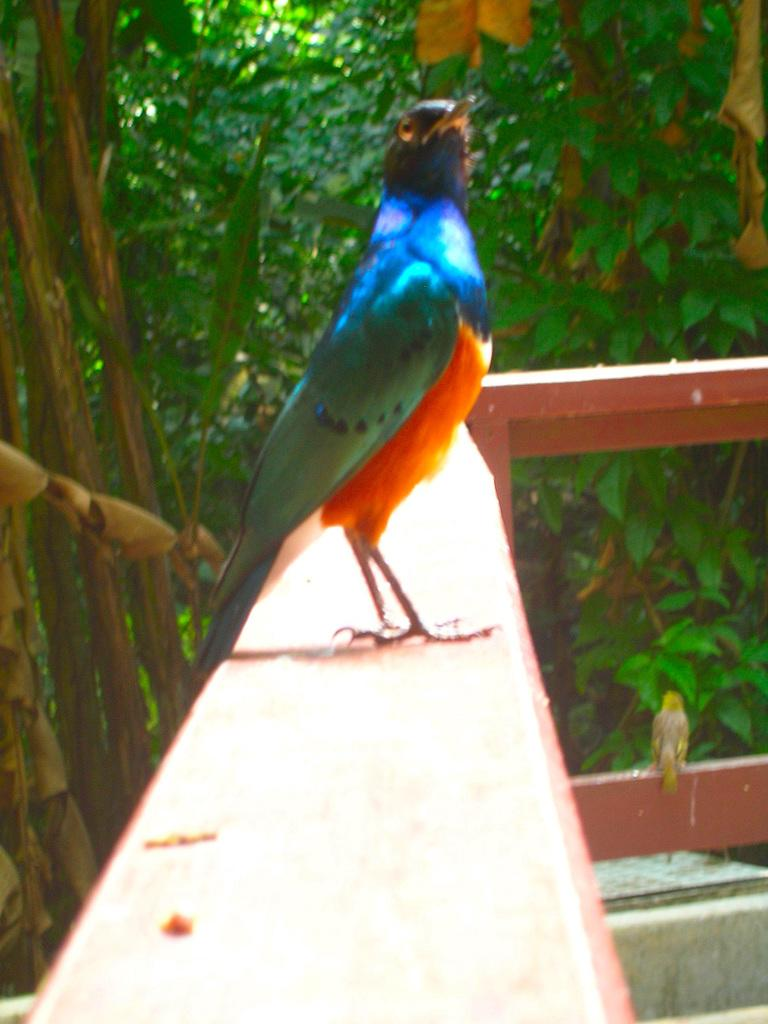What is the main object in the center of the image? There is a board in the center of the image. What can be seen at the bottom of the image? There is a fence at the bottom of the image. What type of natural scenery is visible in the background of the image? There are trees in the background of the image. What type of pleasure can be seen enjoying the drum in the image? There is no drum or pleasure present in the image; it features a board and a fence. Is there a carpenter working on the board in the image? The image does not provide information about whether a carpenter is working on the board or not. 